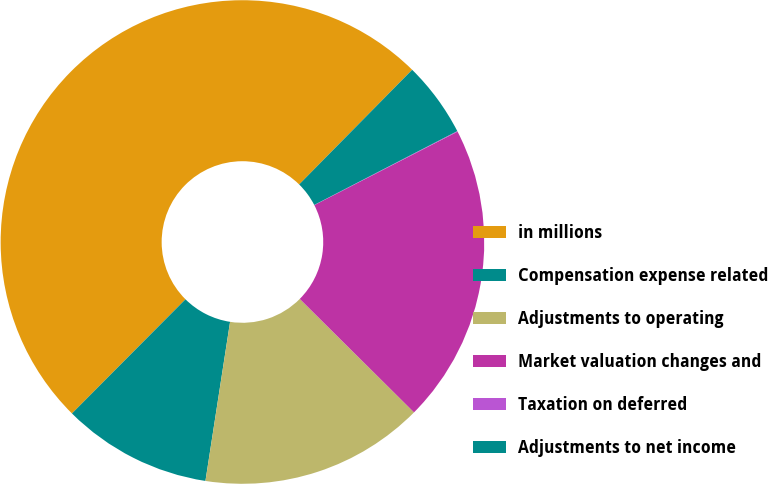Convert chart to OTSL. <chart><loc_0><loc_0><loc_500><loc_500><pie_chart><fcel>in millions<fcel>Compensation expense related<fcel>Adjustments to operating<fcel>Market valuation changes and<fcel>Taxation on deferred<fcel>Adjustments to net income<nl><fcel>49.93%<fcel>10.01%<fcel>15.0%<fcel>19.99%<fcel>0.04%<fcel>5.03%<nl></chart> 